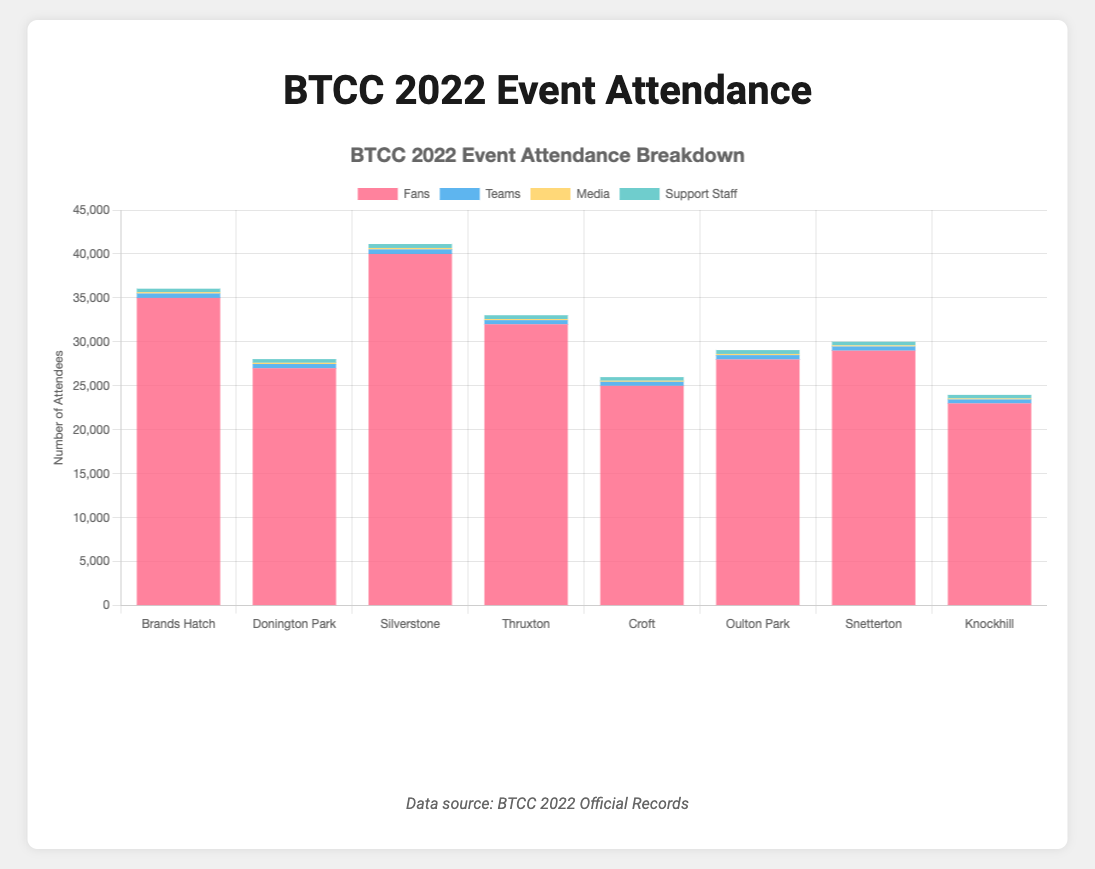How many more fans attended Silverstone compared to Knockhill? To find the difference in the number of fans between Silverstone and Knockhill, subtract the number of fans at Knockhill from the number of fans at Silverstone: 40000 - 23000 = 17000
Answer: 17000 Which event had the highest total number of participants (including Fans, Teams, Media, and Support Staff)? Sum the participants for each event and compare. Silverstone had: 40000 (Fans) + 520 (Teams) + 160 (Media) + 450 (Support Staff) = 41130, which is the highest among all events.
Answer: Silverstone What is the average number of fans per event? Sum the number of fans of all events and divide by the number of events: (35000 + 27000 + 40000 + 32000 + 25000 + 28000 + 29000 + 23000) / 8 = 29900
Answer: 29900 Which category had the smallest total number of participants across all events? Sum the participants for each category across all events and compare: Fans (239000), Teams (3845), Media (1075), Support Staff (3370). Media has the smallest total: 1075
Answer: Media How many more media personnel were there at Brands Hatch compared to Snetterton? Subtract the number of media personnel at Snetterton from the number at Brands Hatch: 150 - 125 = 25
Answer: 25 Which event had the tallest stacked bar visually on the chart, and why? The tallest stacked bar represents the event with the highest total number of participants. Visually, Silverstone had the tallest stacked bar because its total (41130) was the highest among all events.
Answer: Silverstone By how much did the total number of participants at Thruxton exceed those at Croft? Calculate the sum for both events and find the difference: Thruxton (32930) - Croft (25990) = 6940
Answer: 6940 What percentage of the total attendance at Donington Park was fans? Divide the number of fans by the total attendance and multiply by 100: (27000 / 28040) * 100 ≈ 96.29%
Answer: 96.29% Which event had the least number of fans and by how much was it less than the event with the highest number of fans? Knockhill had the least number of fans (23000), and Silverstone had the highest (40000). The difference is 40000 - 23000 = 17000
Answer: 17000 What's the average number of Media personnel per event? Sum the number of Media personnel across all events and divide by the number of events: (150 + 140 + 160 + 130 + 120 + 135 + 125 + 115) / 8 = 134.375 (approx. 134)
Answer: 134 